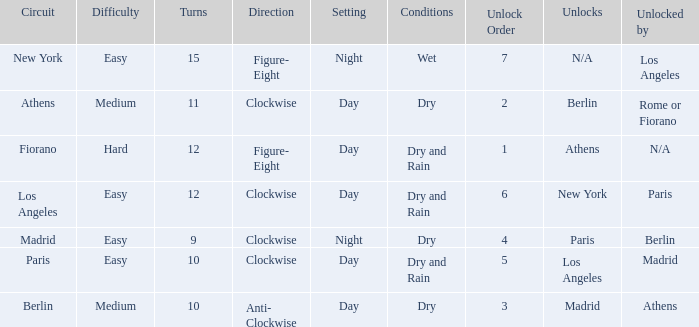What is the setting for the hard difficulty? Day. 